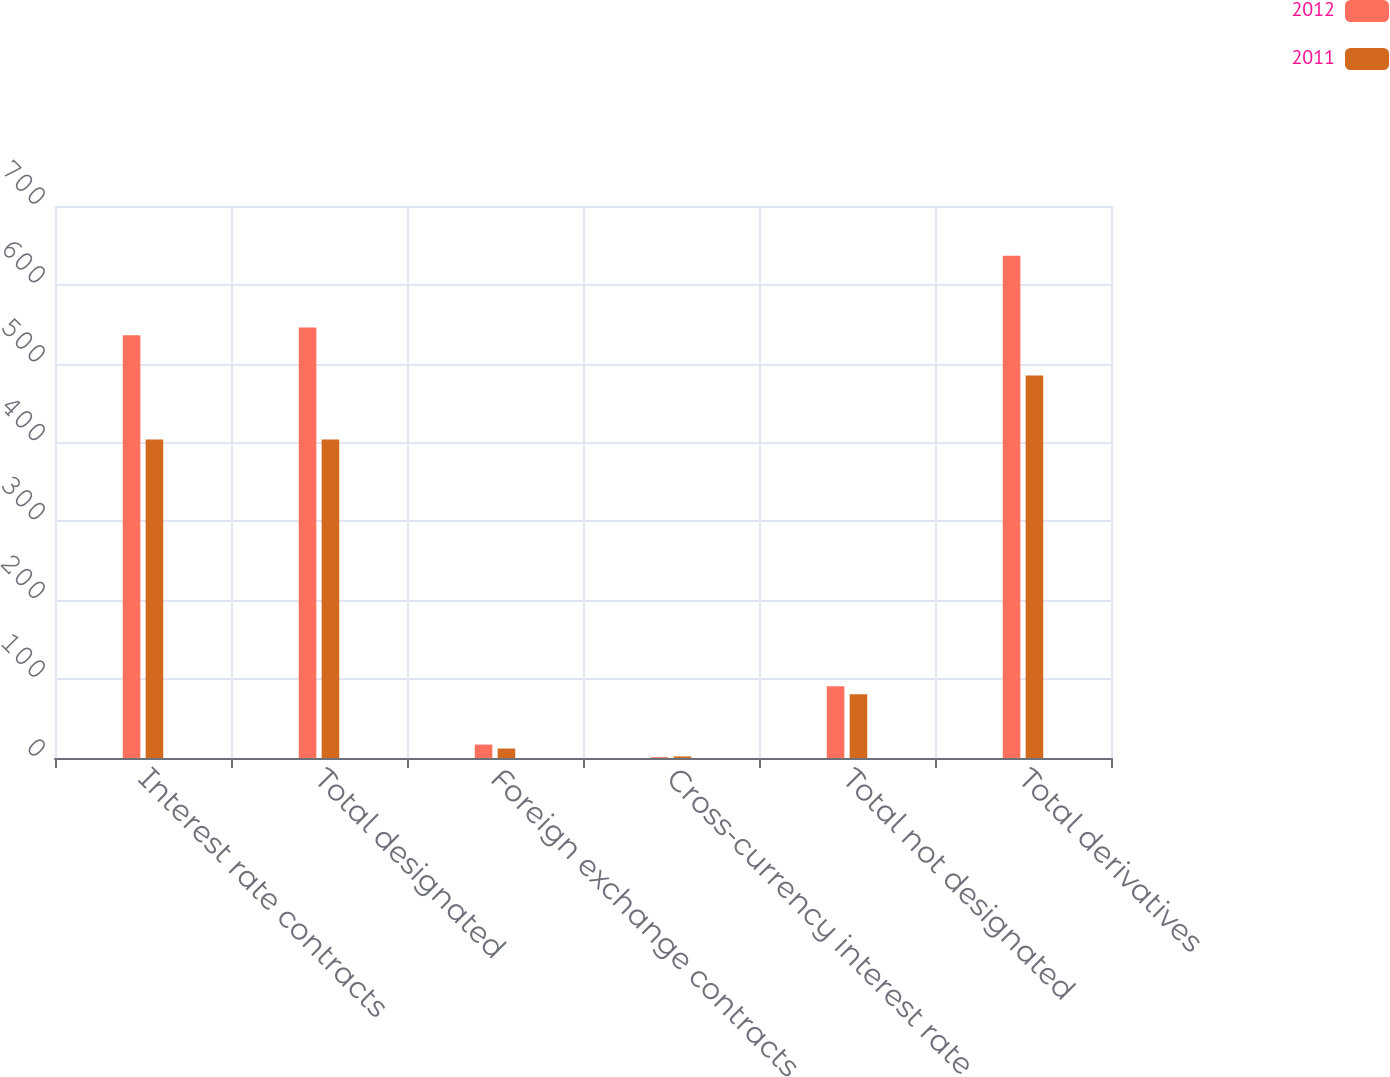Convert chart to OTSL. <chart><loc_0><loc_0><loc_500><loc_500><stacked_bar_chart><ecel><fcel>Interest rate contracts<fcel>Total designated<fcel>Foreign exchange contracts<fcel>Cross-currency interest rate<fcel>Total not designated<fcel>Total derivatives<nl><fcel>2012<fcel>536<fcel>546<fcel>17<fcel>1<fcel>91<fcel>637<nl><fcel>2011<fcel>404<fcel>404<fcel>12<fcel>2<fcel>81<fcel>485<nl></chart> 